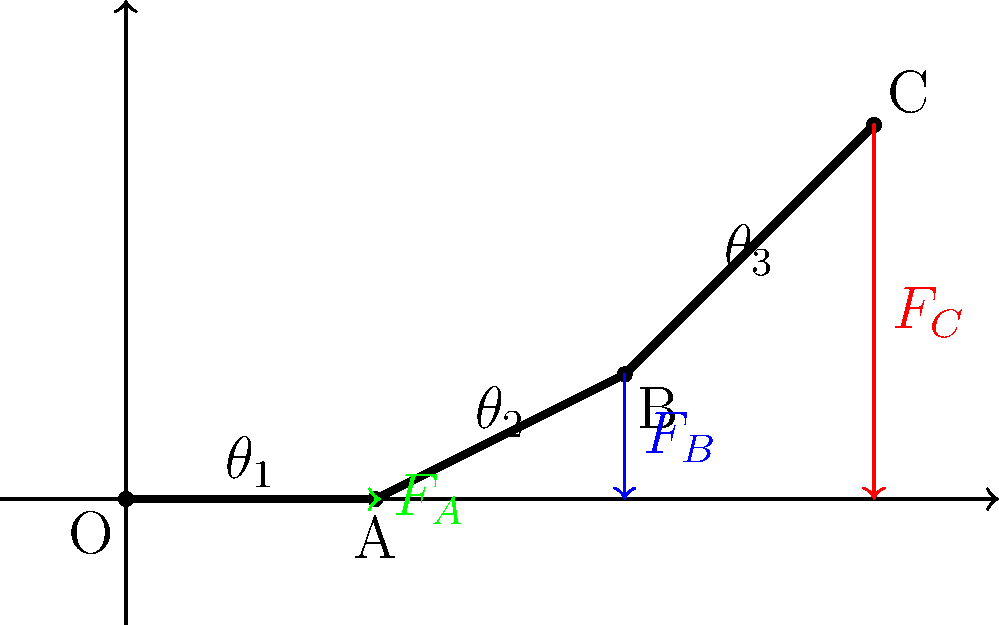In a robotic arm designed for precise music instrument manipulation, three joints (A, B, and C) experience vertical forces $F_A$, $F_B$, and $F_C$ respectively. Given that the total force at the end effector (point C) is 100 N, and the arm segments have lengths $l_1 = 2$ m, $l_2 = 2.24$ m, and $l_3 = 2.83$ m, with angles $\theta_1 = 0°$, $\theta_2 = 30°$, and $\theta_3 = 45°$, calculate the force $F_A$ at joint A. To solve this problem, we'll use the principle of moments and work backwards from the end effector:

1) First, we need to find the horizontal distances from each joint to point C:
   $d_C = 0$ m
   $d_B = l_3 \cos(\theta_3) = 2.83 \cos(45°) = 2$ m
   $d_A = l_2 \cos(\theta_2) + l_3 \cos(\theta_3) = 2.24 \cos(30°) + 2 = 3.94$ m

2) Now, we can set up the moment equation around point O:
   $F_C \cdot 6 + F_B \cdot 4 + F_A \cdot 2 = 100 \cdot 6$

3) We know $F_C = 100$ N, but we need to find $F_B$ to solve for $F_A$. Let's use the moment equation around point A:
   $F_C \cdot 3.94 + F_B \cdot 2 = 100 \cdot 3.94$

4) Solving for $F_B$:
   $F_B = \frac{100 \cdot 3.94 - 100 \cdot 3.94}{2} = 0$ N

5) Now we can substitute this back into the equation from step 2:
   $100 \cdot 6 + 0 \cdot 4 + F_A \cdot 2 = 100 \cdot 6$

6) Solving for $F_A$:
   $F_A \cdot 2 = 100 \cdot 6 - 100 \cdot 6 = 0$
   $F_A = 0$ N

Therefore, the force at joint A is 0 N. This makes sense physically, as the moment created by the force at C is entirely balanced by the distance from O to C.
Answer: $F_A = 0$ N 